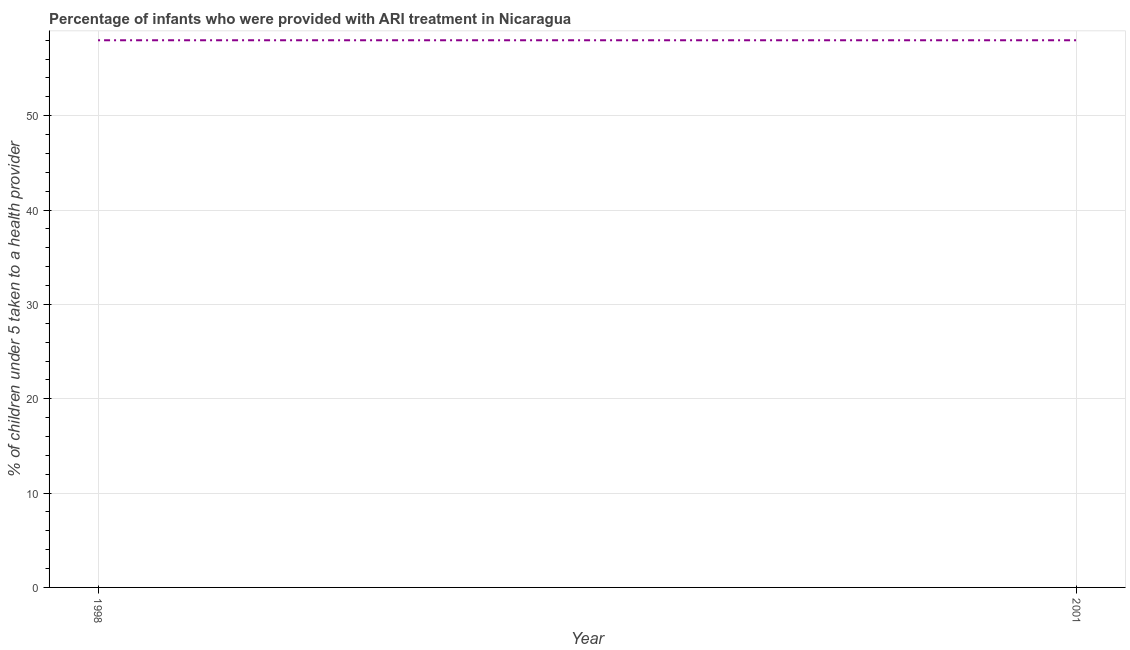What is the percentage of children who were provided with ari treatment in 2001?
Keep it short and to the point. 58. Across all years, what is the maximum percentage of children who were provided with ari treatment?
Your response must be concise. 58. Across all years, what is the minimum percentage of children who were provided with ari treatment?
Keep it short and to the point. 58. In which year was the percentage of children who were provided with ari treatment minimum?
Provide a short and direct response. 1998. What is the sum of the percentage of children who were provided with ari treatment?
Provide a short and direct response. 116. What is the difference between the percentage of children who were provided with ari treatment in 1998 and 2001?
Offer a very short reply. 0. What is the average percentage of children who were provided with ari treatment per year?
Provide a succinct answer. 58. What is the median percentage of children who were provided with ari treatment?
Your answer should be very brief. 58. What is the ratio of the percentage of children who were provided with ari treatment in 1998 to that in 2001?
Give a very brief answer. 1. Is the percentage of children who were provided with ari treatment in 1998 less than that in 2001?
Provide a succinct answer. No. How many years are there in the graph?
Keep it short and to the point. 2. What is the difference between two consecutive major ticks on the Y-axis?
Your answer should be compact. 10. Are the values on the major ticks of Y-axis written in scientific E-notation?
Provide a short and direct response. No. Does the graph contain any zero values?
Your answer should be very brief. No. What is the title of the graph?
Offer a terse response. Percentage of infants who were provided with ARI treatment in Nicaragua. What is the label or title of the Y-axis?
Your response must be concise. % of children under 5 taken to a health provider. What is the % of children under 5 taken to a health provider of 1998?
Give a very brief answer. 58. What is the % of children under 5 taken to a health provider in 2001?
Offer a very short reply. 58. 